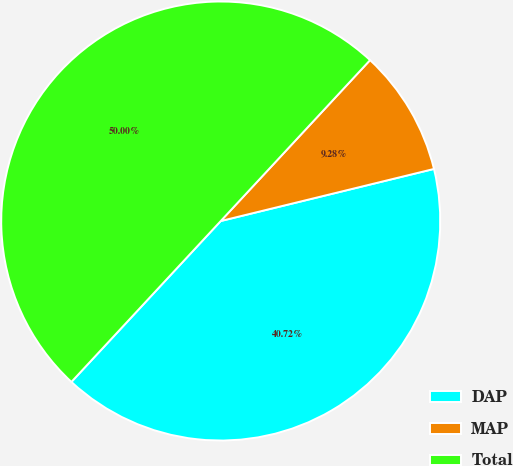<chart> <loc_0><loc_0><loc_500><loc_500><pie_chart><fcel>DAP<fcel>MAP<fcel>Total<nl><fcel>40.72%<fcel>9.28%<fcel>50.0%<nl></chart> 